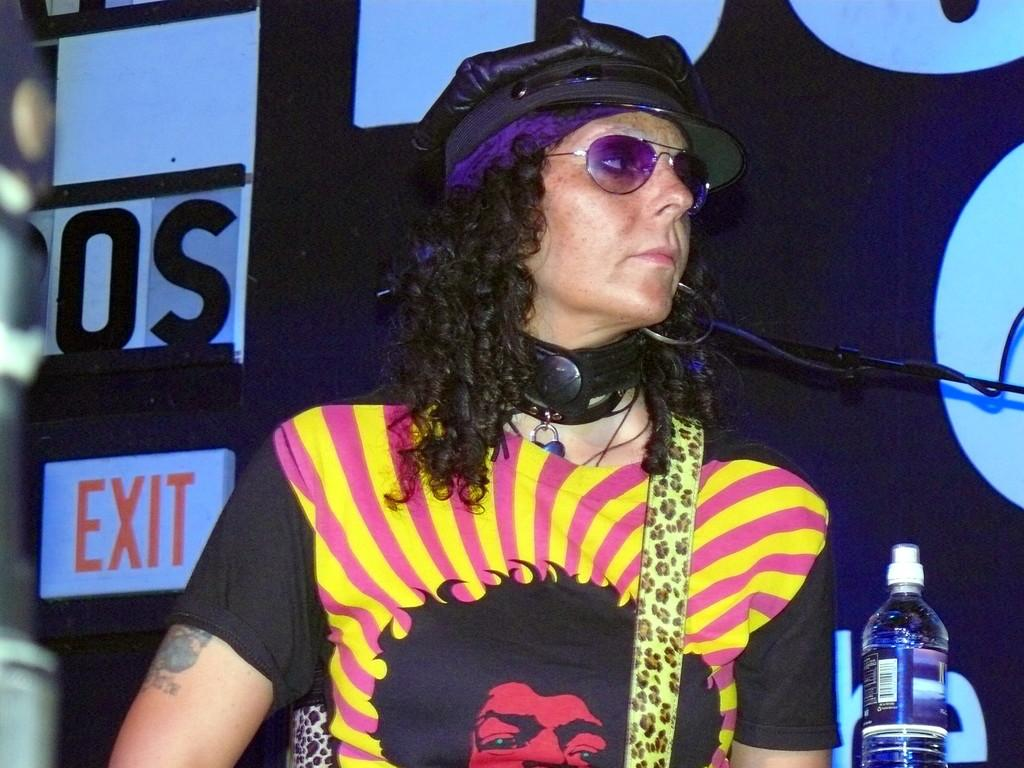What can be seen in the image? There is a person in the image. What is the person wearing on their face? The person is wearing goggles. What is the person wearing on their head? The person is wearing a cap. What object is in front of the person? There is a bottle in front of the person. What can be seen in the background of the image? There is a wall and a board in the background of the image. What type of yoke is being used by the person in the image? There is no yoke present in the image. What type of oil is being used by the person in the image? There is no oil or any indication of oil usage in the image. 